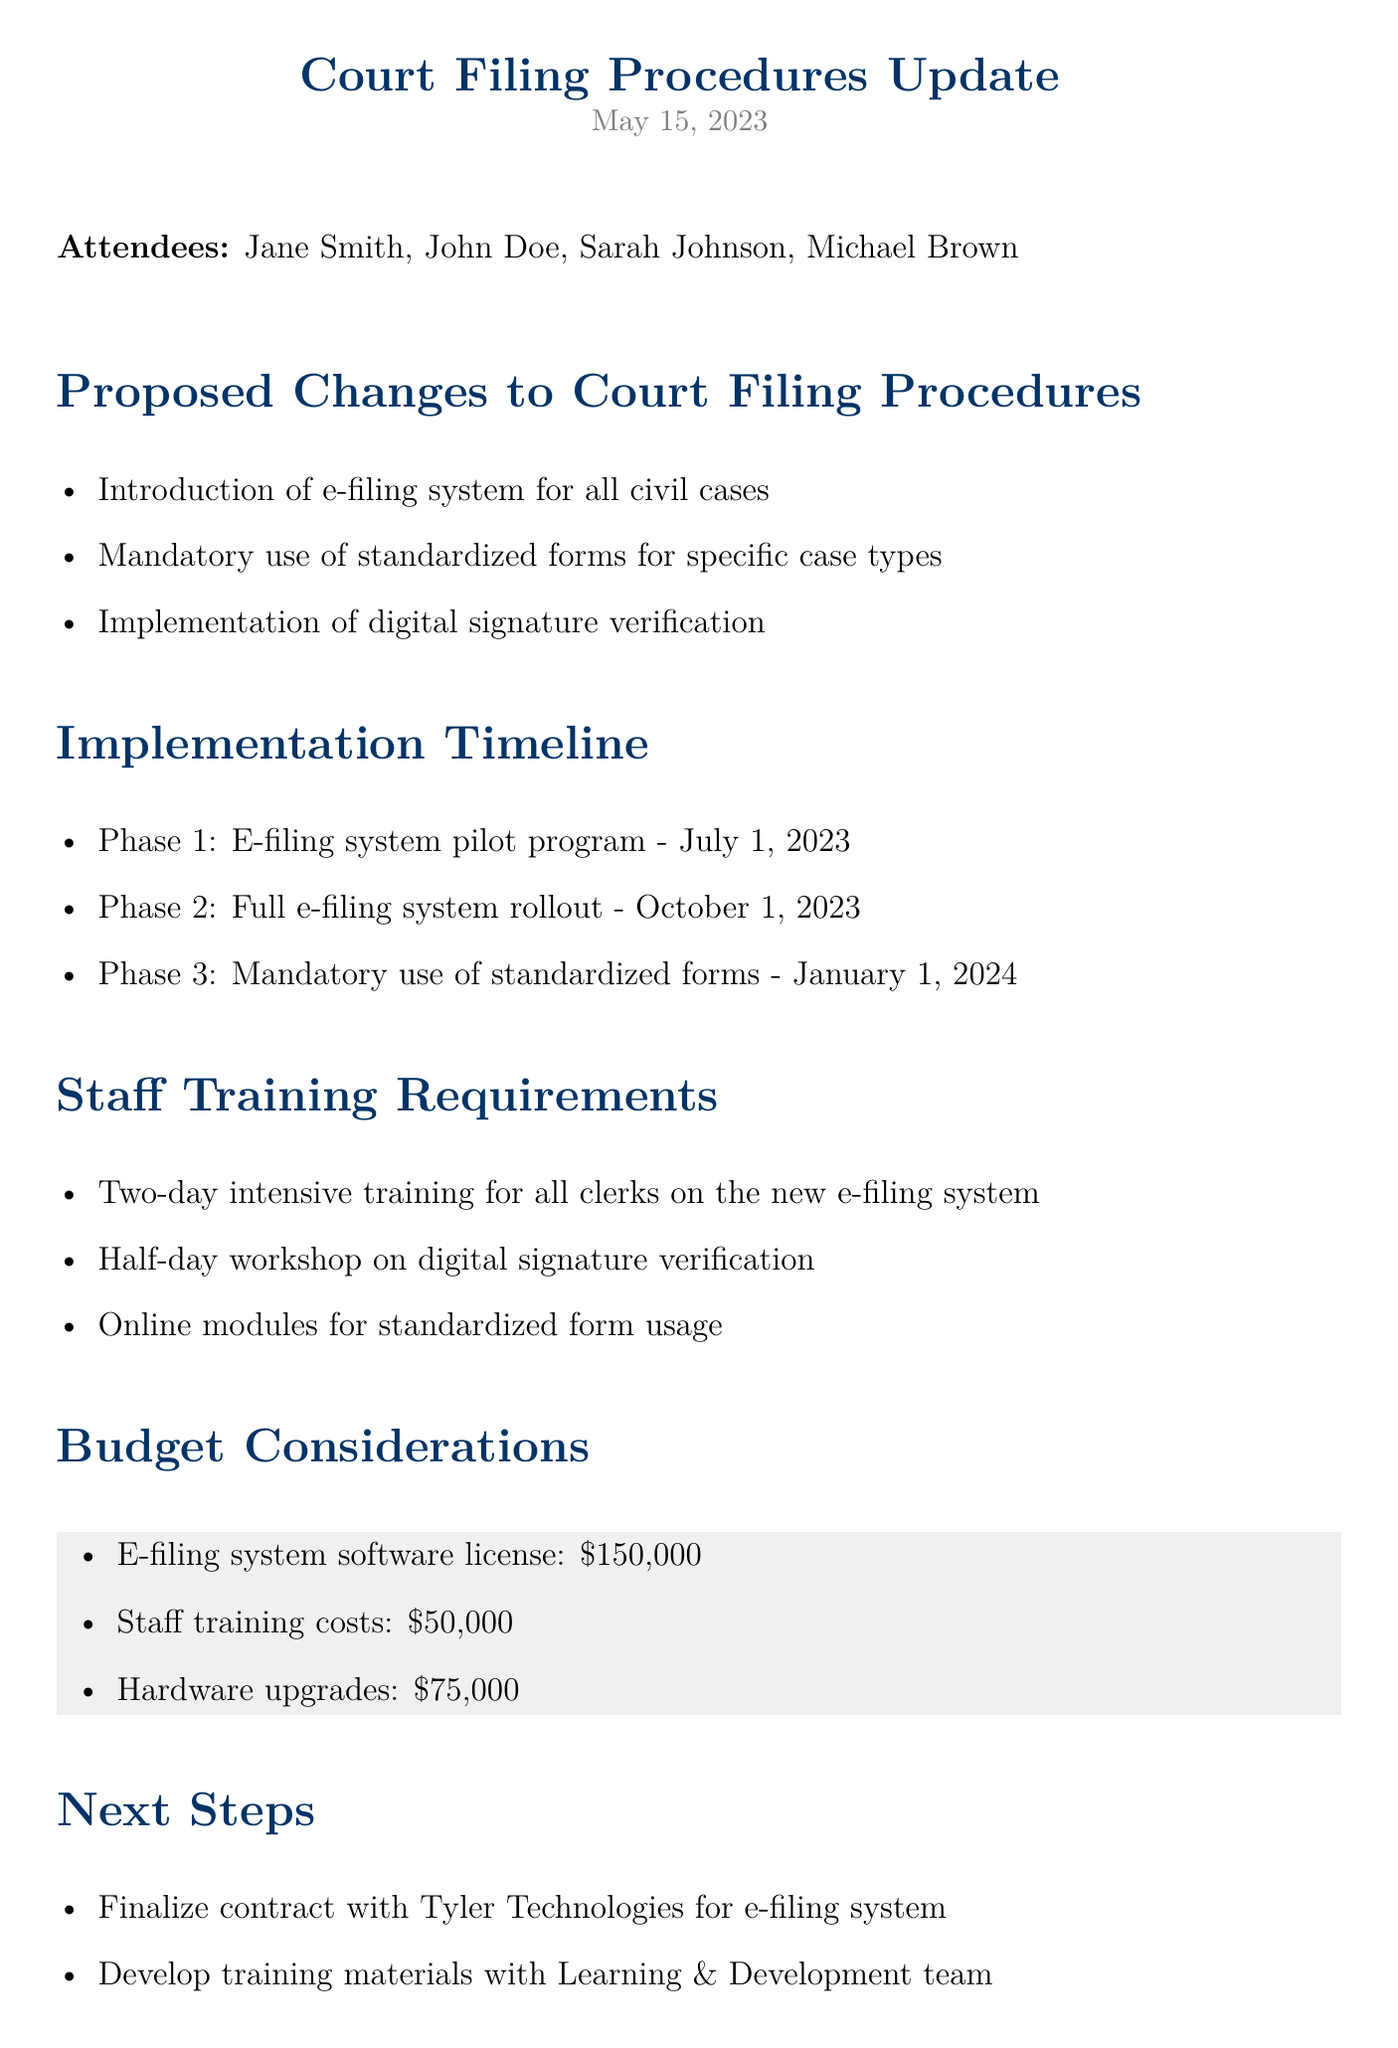what is the date of the meeting? The date of the meeting is explicitly mentioned in the document as May 15, 2023.
Answer: May 15, 2023 who introduced the proposed changes to court filing procedures? The minutes list Jane Smith as the author of the minutes, indicating her role in leading the discussion.
Answer: Jane Smith what is the budget for staff training costs? The document specifies that the staff training costs amount to $50,000.
Answer: $50,000 when is the full e-filing system rollout scheduled? The document outlines the implementation timeline and states that the full rollout is set for October 1, 2023.
Answer: October 1, 2023 how long is the intensive training for clerks on the new e-filing system? The document clearly states that the training will last for two days.
Answer: Two days what are the next steps listed in the document? The document outlines next steps including finalizing a contract and developing training materials.
Answer: Finalize contract, develop training materials what is the phase before the mandatory use of standardized forms? The second phase in the implementation timeline addresses the full e-filing system rollout.
Answer: Full e-filing system rollout how will staff be trained on digital signature verification? The minutes specify a half-day workshop as the method of training for digital signature verification.
Answer: Half-day workshop 